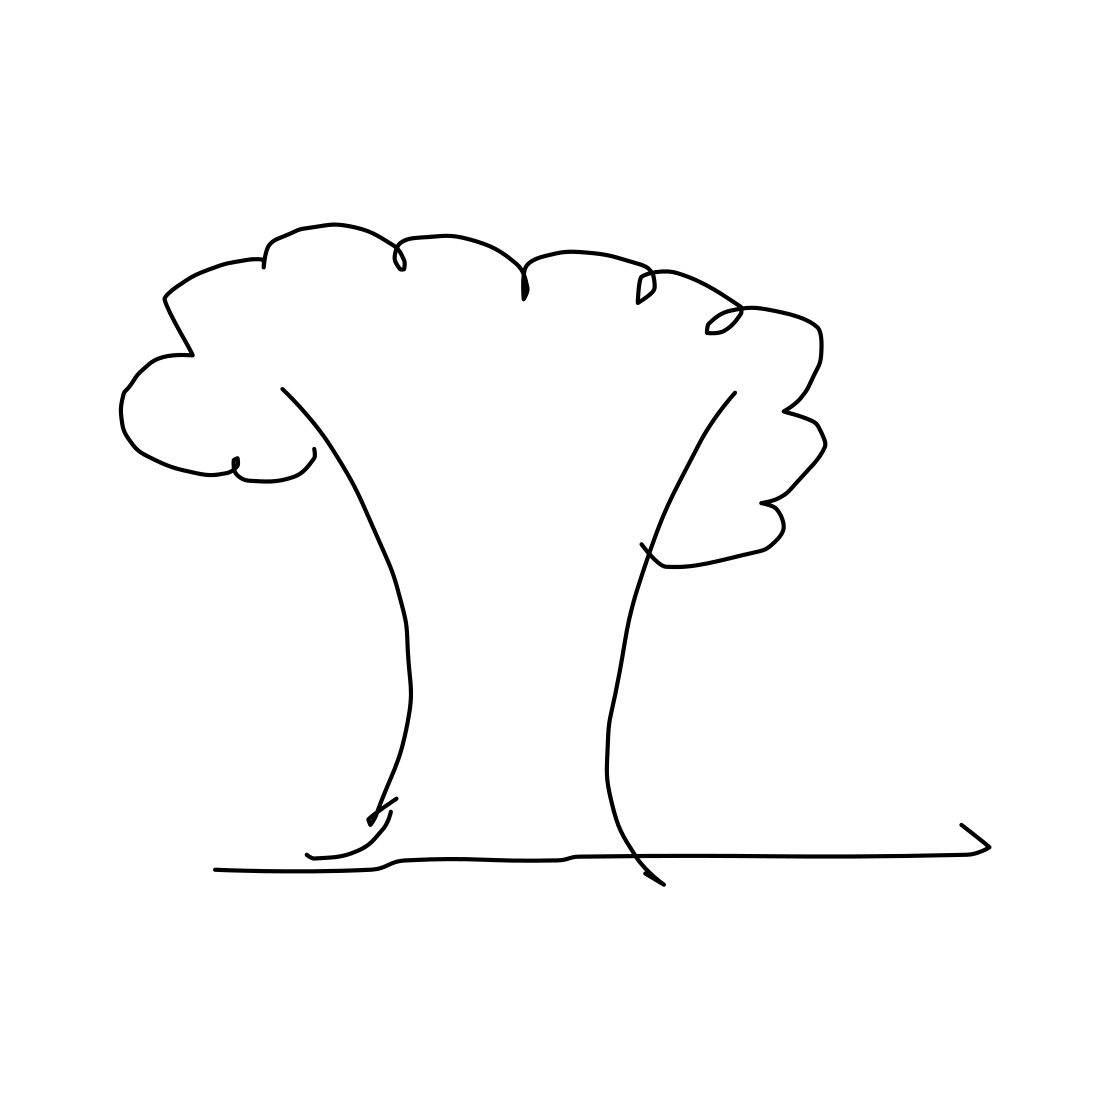Could you tell me more about the artistic style of this tree? The tree is drawn in a minimalist, sketch-like style, using continuous lines without much detail. This type of drawing might be used in educational settings to illustrate basic concepts or serve as an iconographic representation. 